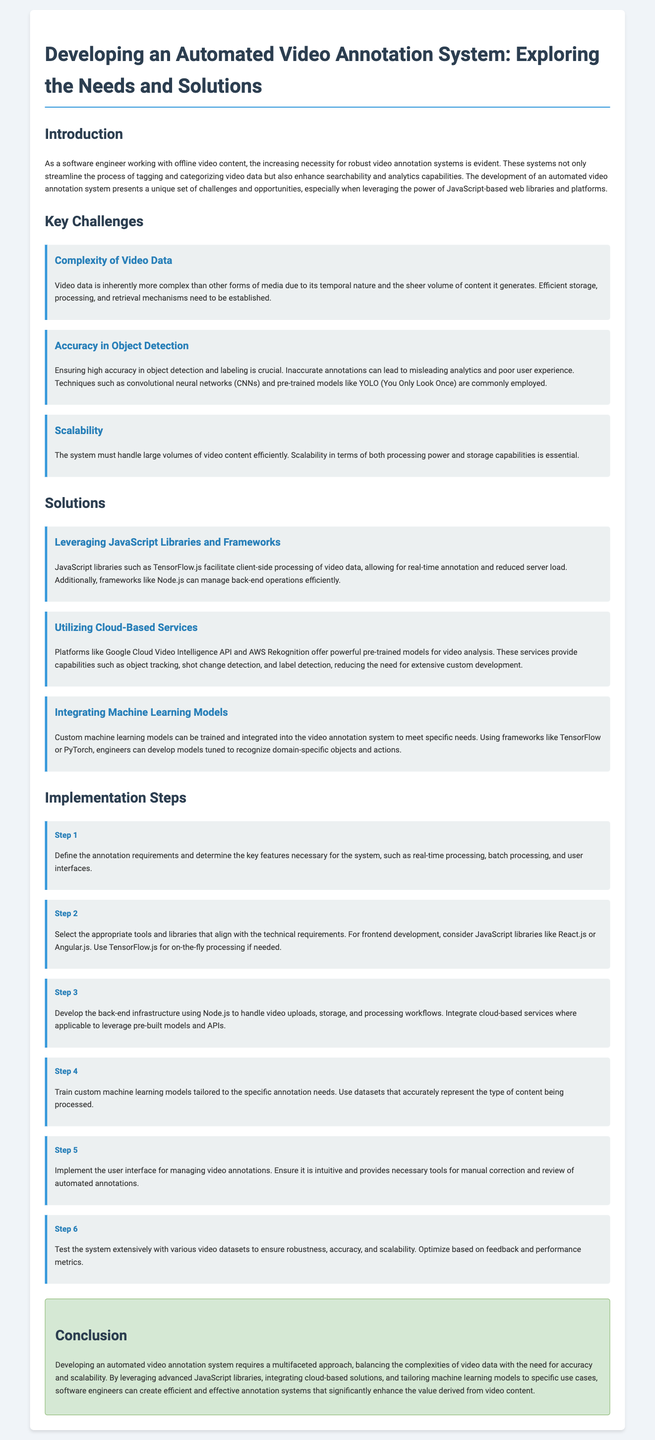what is the title of the document? The title is found at the top of the document.
Answer: Developing an Automated Video Annotation System: Exploring the Needs and Solutions what are the key challenges mentioned? The challenges can be found under the "Key Challenges" section of the document.
Answer: Complexity of Video Data, Accuracy in Object Detection, Scalability which JavaScript library is mentioned for client-side processing? This information is located in the "Solutions" section where specific tools are discussed.
Answer: TensorFlow.js what is one of the solutions for ensuring high accuracy in object detection? This is detailed in the "Accuracy in Object Detection" challenge where techniques are described.
Answer: Convolutional neural networks how many implementation steps are outlined? The number of steps can be counted from the "Implementation Steps" section.
Answer: Six what is the main purpose of the automated video annotation system? The purpose is discussed in the introduction as the system's role in enhancing video content functionality.
Answer: Streamline tagging and categorizing video data which service is suggested for leveraging pre-trained models? This is referenced in the "Utilizing Cloud-Based Services" solution.
Answer: Google Cloud Video Intelligence API what is the final step in the implementation process? The final step is found in the list of steps outlined in the "Implementation Steps" section.
Answer: Test the system extensively 